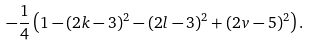<formula> <loc_0><loc_0><loc_500><loc_500>- \frac { 1 } { 4 } \left ( 1 - ( 2 k - 3 ) ^ { 2 } - ( 2 l - 3 ) ^ { 2 } + ( 2 v - 5 ) ^ { 2 } \right ) .</formula> 